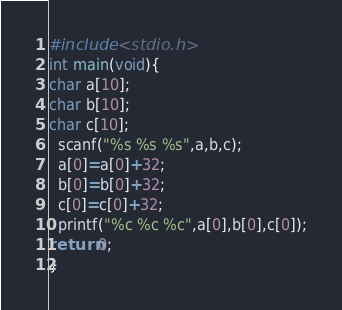Convert code to text. <code><loc_0><loc_0><loc_500><loc_500><_C_>#include <stdio.h>
int main(void){
char a[10];
char b[10];
char c[10];
  scanf("%s %s %s",a,b,c);
  a[0]=a[0]+32;
  b[0]=b[0]+32;
  c[0]=c[0]+32;
  printf("%c %c %c",a[0],b[0],c[0]);
return 0;
}</code> 